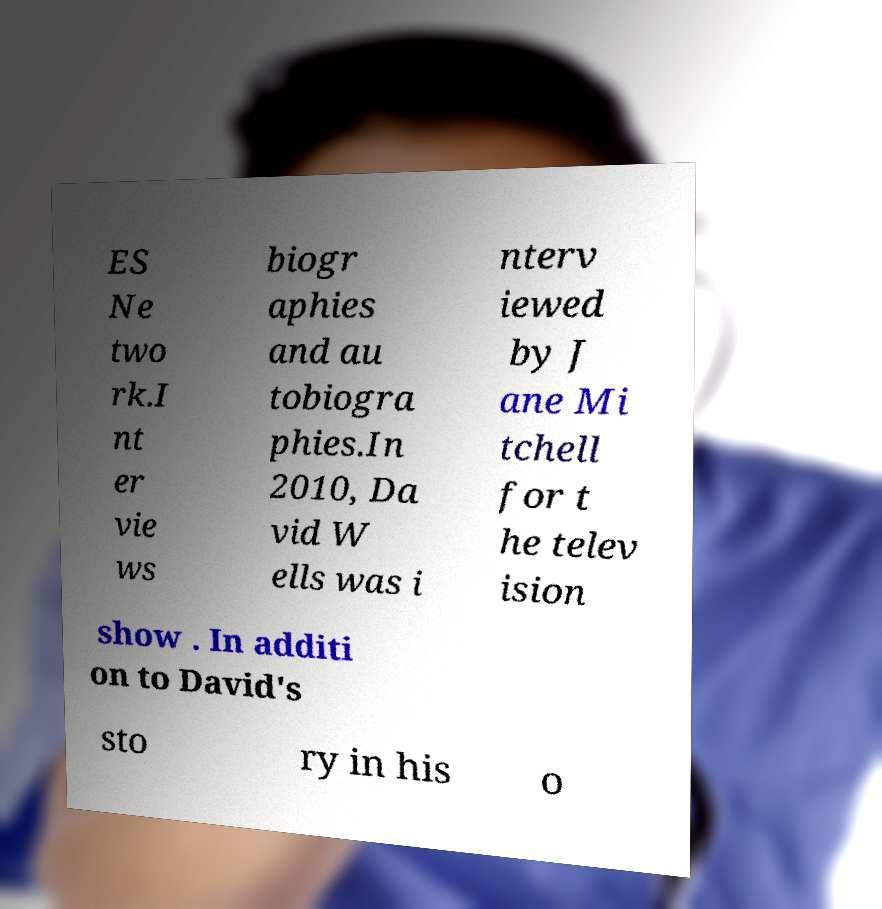What messages or text are displayed in this image? I need them in a readable, typed format. ES Ne two rk.I nt er vie ws biogr aphies and au tobiogra phies.In 2010, Da vid W ells was i nterv iewed by J ane Mi tchell for t he telev ision show . In additi on to David's sto ry in his o 